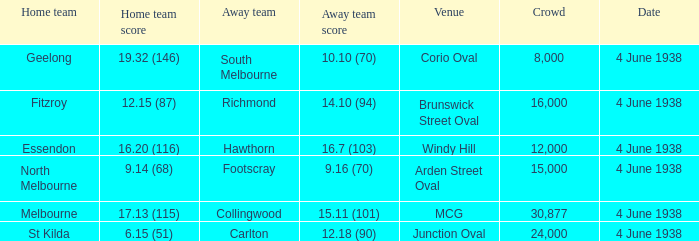What was the score for Geelong? 10.10 (70). 